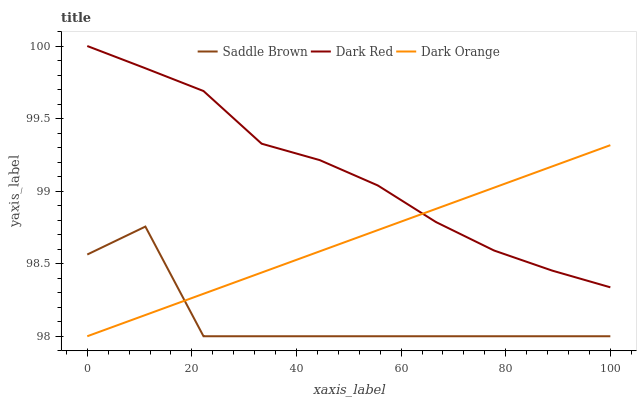Does Saddle Brown have the minimum area under the curve?
Answer yes or no. Yes. Does Dark Red have the maximum area under the curve?
Answer yes or no. Yes. Does Dark Orange have the minimum area under the curve?
Answer yes or no. No. Does Dark Orange have the maximum area under the curve?
Answer yes or no. No. Is Dark Orange the smoothest?
Answer yes or no. Yes. Is Saddle Brown the roughest?
Answer yes or no. Yes. Is Saddle Brown the smoothest?
Answer yes or no. No. Is Dark Orange the roughest?
Answer yes or no. No. Does Saddle Brown have the lowest value?
Answer yes or no. Yes. Does Dark Red have the highest value?
Answer yes or no. Yes. Does Dark Orange have the highest value?
Answer yes or no. No. Is Saddle Brown less than Dark Red?
Answer yes or no. Yes. Is Dark Red greater than Saddle Brown?
Answer yes or no. Yes. Does Saddle Brown intersect Dark Orange?
Answer yes or no. Yes. Is Saddle Brown less than Dark Orange?
Answer yes or no. No. Is Saddle Brown greater than Dark Orange?
Answer yes or no. No. Does Saddle Brown intersect Dark Red?
Answer yes or no. No. 